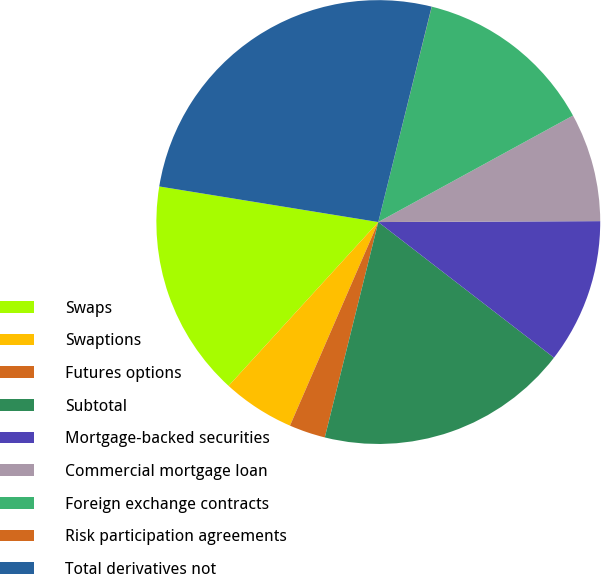<chart> <loc_0><loc_0><loc_500><loc_500><pie_chart><fcel>Swaps<fcel>Swaptions<fcel>Futures options<fcel>Subtotal<fcel>Mortgage-backed securities<fcel>Commercial mortgage loan<fcel>Foreign exchange contracts<fcel>Risk participation agreements<fcel>Total derivatives not<nl><fcel>15.78%<fcel>5.27%<fcel>2.64%<fcel>18.41%<fcel>10.53%<fcel>7.9%<fcel>13.16%<fcel>0.01%<fcel>26.3%<nl></chart> 